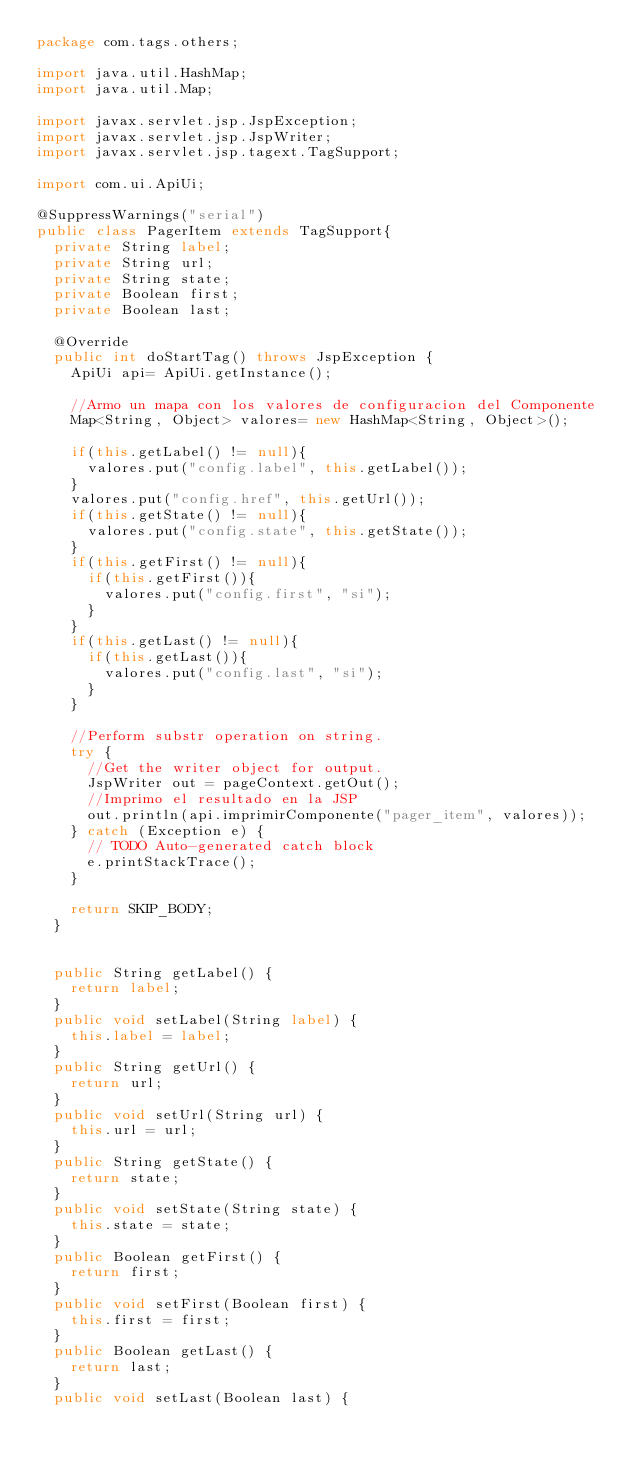Convert code to text. <code><loc_0><loc_0><loc_500><loc_500><_Java_>package com.tags.others;

import java.util.HashMap;
import java.util.Map;

import javax.servlet.jsp.JspException;
import javax.servlet.jsp.JspWriter;
import javax.servlet.jsp.tagext.TagSupport;

import com.ui.ApiUi;

@SuppressWarnings("serial")
public class PagerItem extends TagSupport{
	private String label;
	private String url;
	private String state;
	private Boolean first;
	private Boolean last;	
	
	@Override
	public int doStartTag() throws JspException {
		ApiUi api= ApiUi.getInstance();
		
		//Armo un mapa con los valores de configuracion del Componente
		Map<String, Object> valores= new HashMap<String, Object>();
		
		if(this.getLabel() != null){
			valores.put("config.label", this.getLabel());
		}
		valores.put("config.href", this.getUrl());
		if(this.getState() != null){
			valores.put("config.state", this.getState());
		}
		if(this.getFirst() != null){
			if(this.getFirst()){
				valores.put("config.first", "si");
			}
		}
		if(this.getLast() != null){
			if(this.getLast()){
				valores.put("config.last", "si");
			}
		}		
		
		//Perform substr operation on string.
		try {
			//Get the writer object for output.
			JspWriter out = pageContext.getOut();
			//Imprimo el resultado en la JSP
			out.println(api.imprimirComponente("pager_item", valores));
		} catch (Exception e) {
			// TODO Auto-generated catch block
			e.printStackTrace();
		}
		
		return SKIP_BODY;
	}
	
	
	public String getLabel() {
		return label;
	}
	public void setLabel(String label) {
		this.label = label;
	}
	public String getUrl() {
		return url;
	}
	public void setUrl(String url) {
		this.url = url;
	}
	public String getState() {
		return state;
	}
	public void setState(String state) {
		this.state = state;
	}
	public Boolean getFirst() {
		return first;
	}
	public void setFirst(Boolean first) {
		this.first = first;
	}
	public Boolean getLast() {
		return last;
	}
	public void setLast(Boolean last) {</code> 